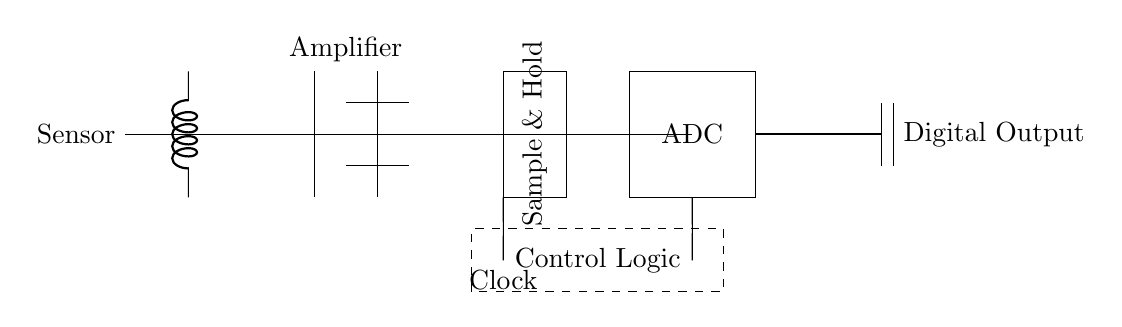What is the first component in the circuit? The circuit diagram shows a Sensor connected to the system, indicating that it is the starting point of the signal processing chain.
Answer: Sensor What type of circuit element is used for the signal processing? The circuit includes an amplifier, sample and hold, and ADC, which are crucial for amplifying, sampling, and digitizing the analog signal.
Answer: Amplifier, Sample and Hold, ADC What is the purpose of the sample and hold component? The sample and hold circuit temporarily holds the signal at a constant level during the conversion process, ensuring that the ADC has a stable input to work with, which is key for accurate digitization.
Answer: To hold the signal constant What is located between the amplifier and the ADC? The sample and hold stage is positioned between these two elements, acting as an intermediary to prepare the signal for proper conversion by the ADC.
Answer: Sample and Hold What does the dashed box in the diagram represent? The dashed box encloses the control logic, which manages the timing and operation of various components in the circuit to ensure proper functionality during data acquisition.
Answer: Control Logic What type of output does the ADC provide? The ADC outputs a digital signal that corresponds to the sampled analog input, completing the conversion process from analog to digital.
Answer: Digital Output What is essential for the timing in this circuit? The clock signal is crucial as it synchronizes operations within the sampling and conversion processes, making it essential for the correct performance of the ADC, sample and hold, and amplifier.
Answer: Clock 